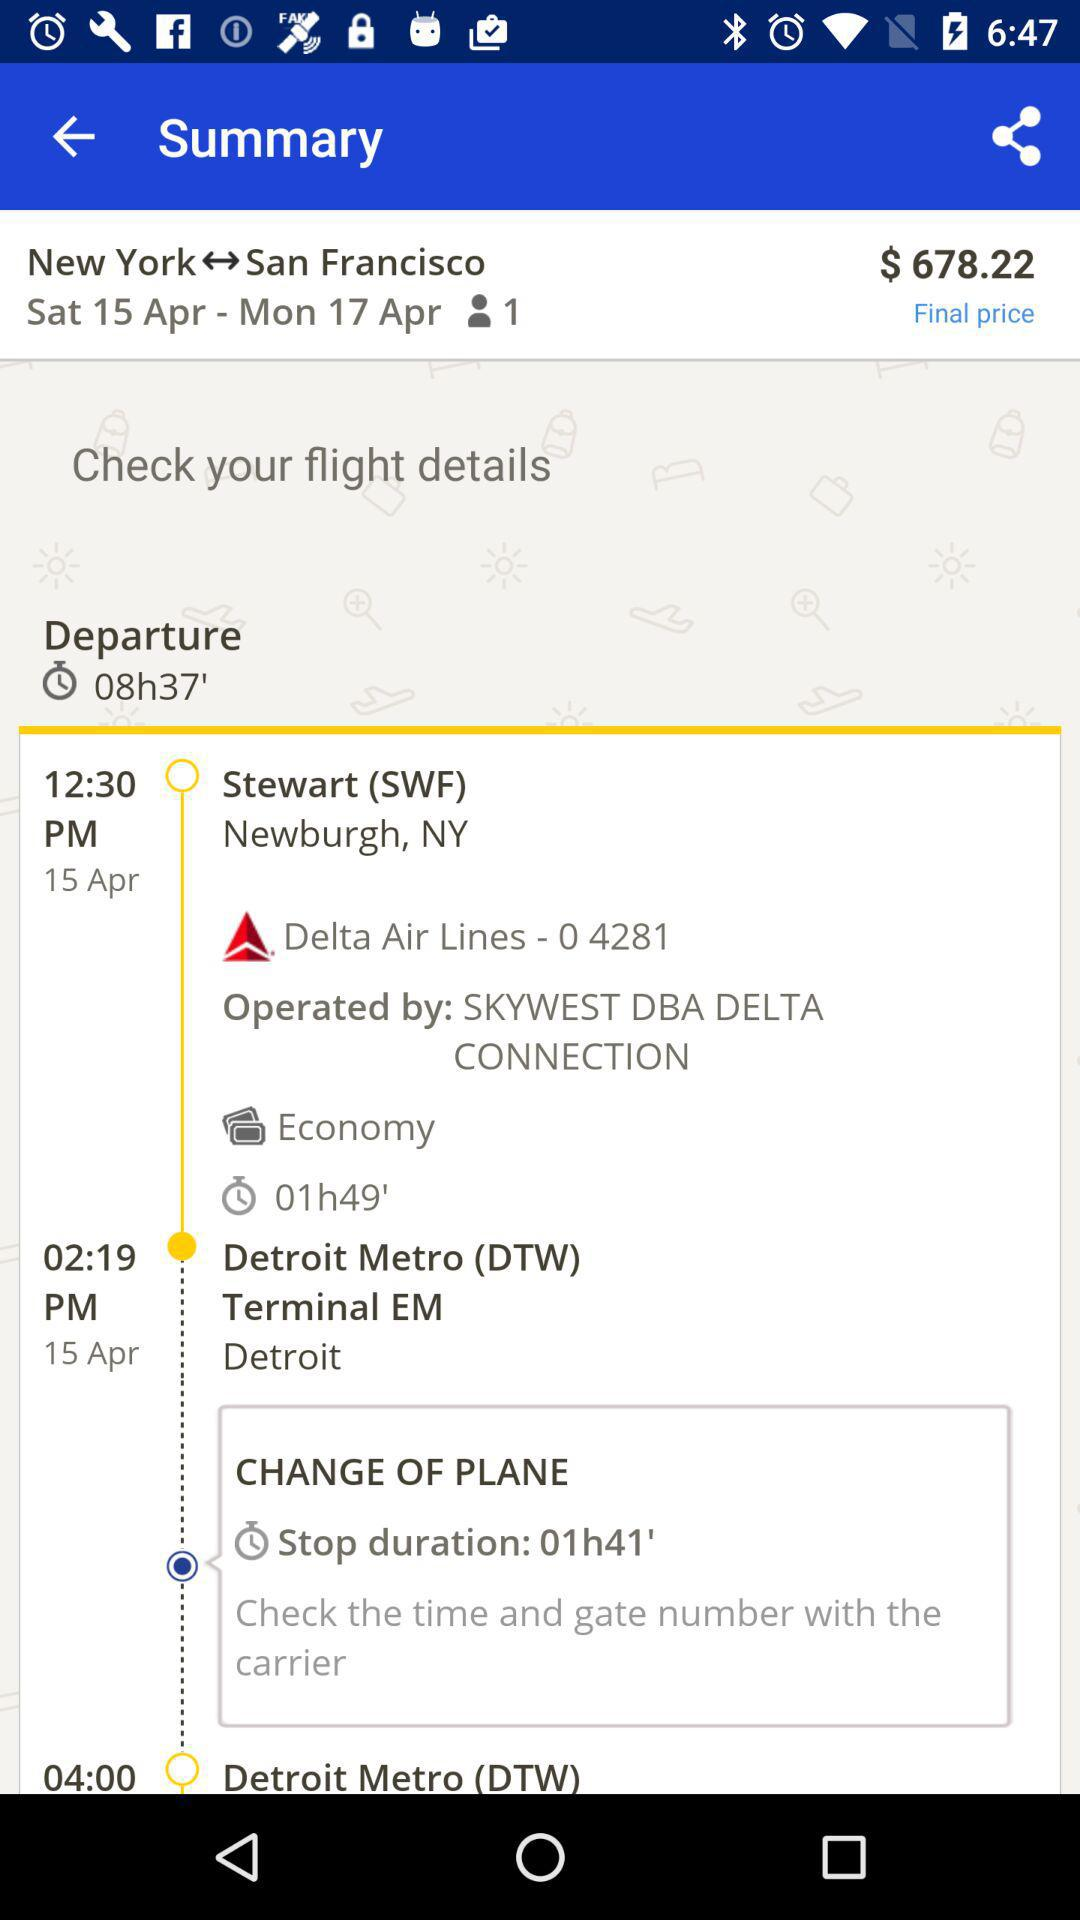What is the departure time? The departure time is 12:30 PM. 